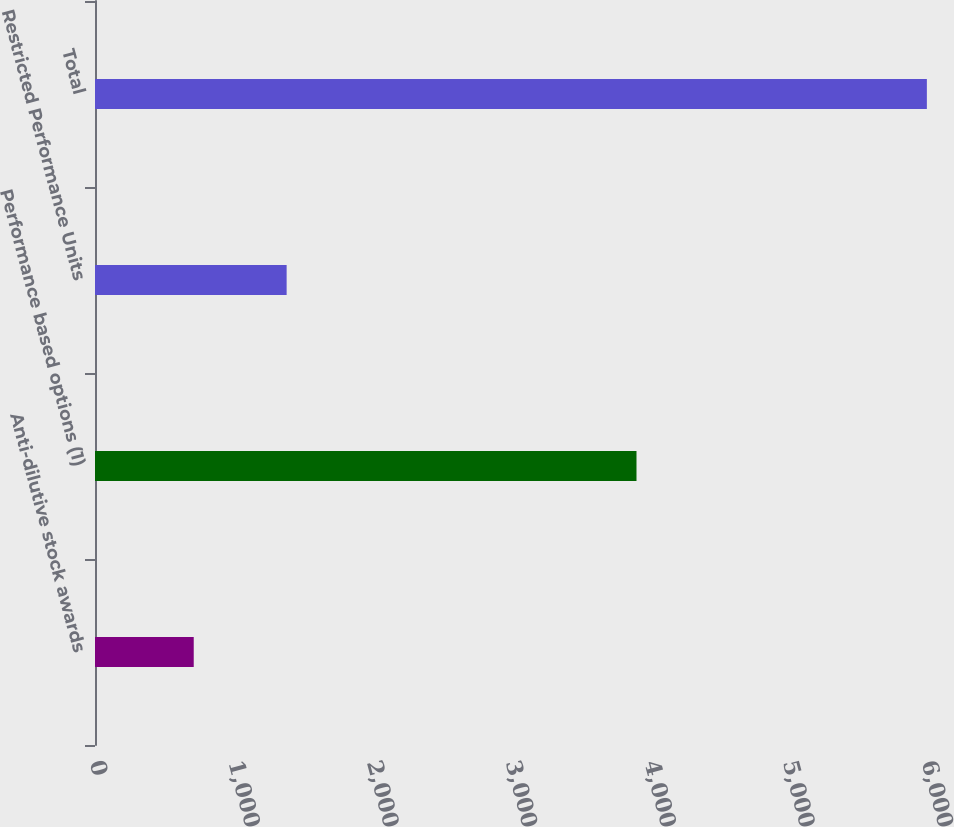Convert chart. <chart><loc_0><loc_0><loc_500><loc_500><bar_chart><fcel>Anti-dilutive stock awards<fcel>Performance based options (1)<fcel>Restricted Performance Units<fcel>Total<nl><fcel>712<fcel>3905<fcel>1382<fcel>5999<nl></chart> 